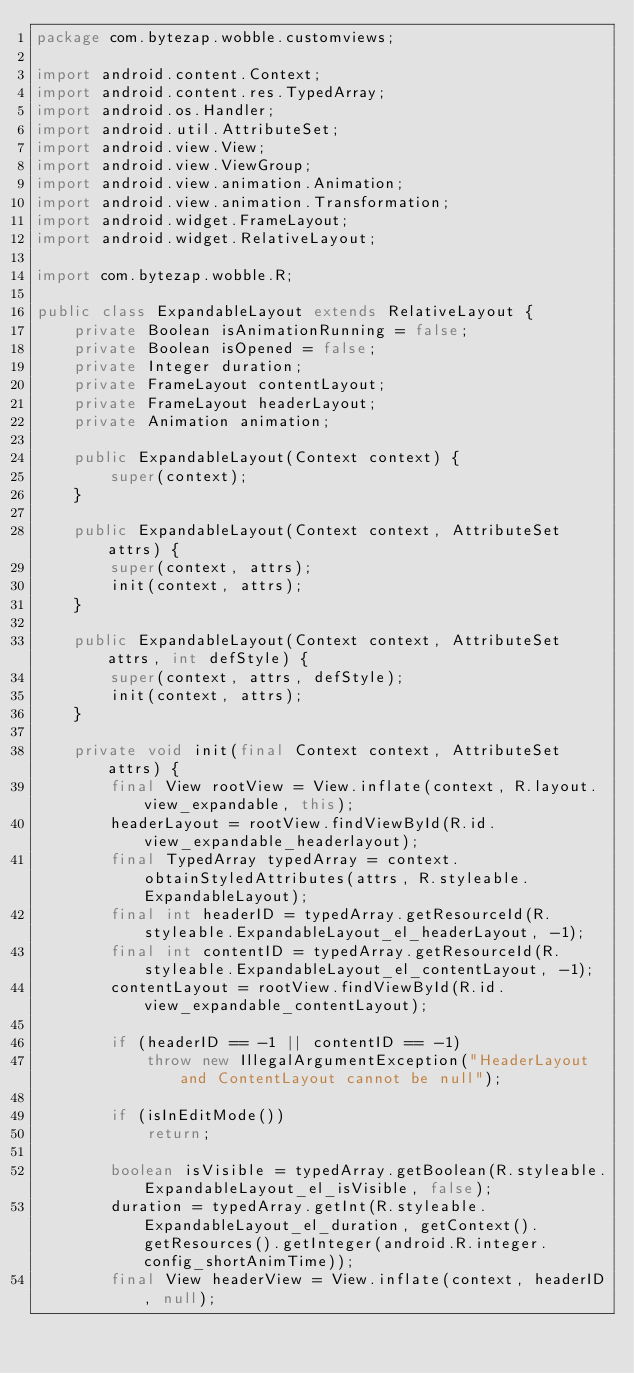<code> <loc_0><loc_0><loc_500><loc_500><_Java_>package com.bytezap.wobble.customviews;

import android.content.Context;
import android.content.res.TypedArray;
import android.os.Handler;
import android.util.AttributeSet;
import android.view.View;
import android.view.ViewGroup;
import android.view.animation.Animation;
import android.view.animation.Transformation;
import android.widget.FrameLayout;
import android.widget.RelativeLayout;

import com.bytezap.wobble.R;

public class ExpandableLayout extends RelativeLayout {
    private Boolean isAnimationRunning = false;
    private Boolean isOpened = false;
    private Integer duration;
    private FrameLayout contentLayout;
    private FrameLayout headerLayout;
    private Animation animation;

    public ExpandableLayout(Context context) {
        super(context);
    }

    public ExpandableLayout(Context context, AttributeSet attrs) {
        super(context, attrs);
        init(context, attrs);
    }

    public ExpandableLayout(Context context, AttributeSet attrs, int defStyle) {
        super(context, attrs, defStyle);
        init(context, attrs);
    }

    private void init(final Context context, AttributeSet attrs) {
        final View rootView = View.inflate(context, R.layout.view_expandable, this);
        headerLayout = rootView.findViewById(R.id.view_expandable_headerlayout);
        final TypedArray typedArray = context.obtainStyledAttributes(attrs, R.styleable.ExpandableLayout);
        final int headerID = typedArray.getResourceId(R.styleable.ExpandableLayout_el_headerLayout, -1);
        final int contentID = typedArray.getResourceId(R.styleable.ExpandableLayout_el_contentLayout, -1);
        contentLayout = rootView.findViewById(R.id.view_expandable_contentLayout);

        if (headerID == -1 || contentID == -1)
            throw new IllegalArgumentException("HeaderLayout and ContentLayout cannot be null");

        if (isInEditMode())
            return;

        boolean isVisible = typedArray.getBoolean(R.styleable.ExpandableLayout_el_isVisible, false);
        duration = typedArray.getInt(R.styleable.ExpandableLayout_el_duration, getContext().getResources().getInteger(android.R.integer.config_shortAnimTime));
        final View headerView = View.inflate(context, headerID, null);</code> 